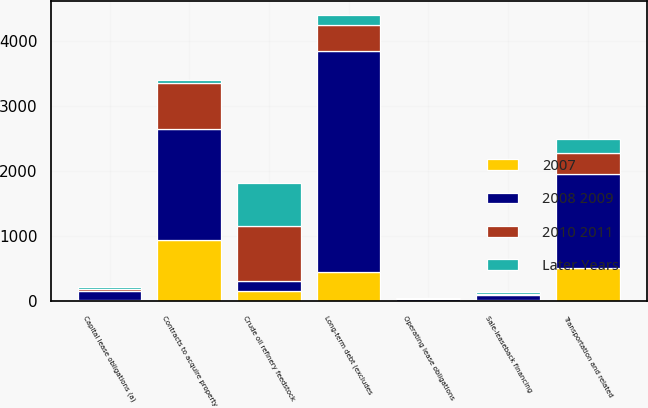Convert chart to OTSL. <chart><loc_0><loc_0><loc_500><loc_500><stacked_bar_chart><ecel><fcel>Long-term debt (excludes<fcel>Sale-leaseback financing<fcel>Capital lease obligations (a)<fcel>Operating lease obligations<fcel>Crude oil refinery feedstock<fcel>Transportation and related<fcel>Contracts to acquire property<nl><fcel>2008 2009<fcel>3398<fcel>75<fcel>141<fcel>32<fcel>156<fcel>1445<fcel>1703<nl><fcel>2007<fcel>450<fcel>20<fcel>16<fcel>5<fcel>156<fcel>515<fcel>935<nl><fcel>2010 2011<fcel>400<fcel>22<fcel>33<fcel>11<fcel>852<fcel>323<fcel>719<nl><fcel>Later Years<fcel>143<fcel>22<fcel>33<fcel>11<fcel>655<fcel>201<fcel>37<nl></chart> 